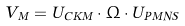Convert formula to latex. <formula><loc_0><loc_0><loc_500><loc_500>V _ { M } = U _ { C K M } \cdot \Omega \cdot U _ { P M N S } \,</formula> 